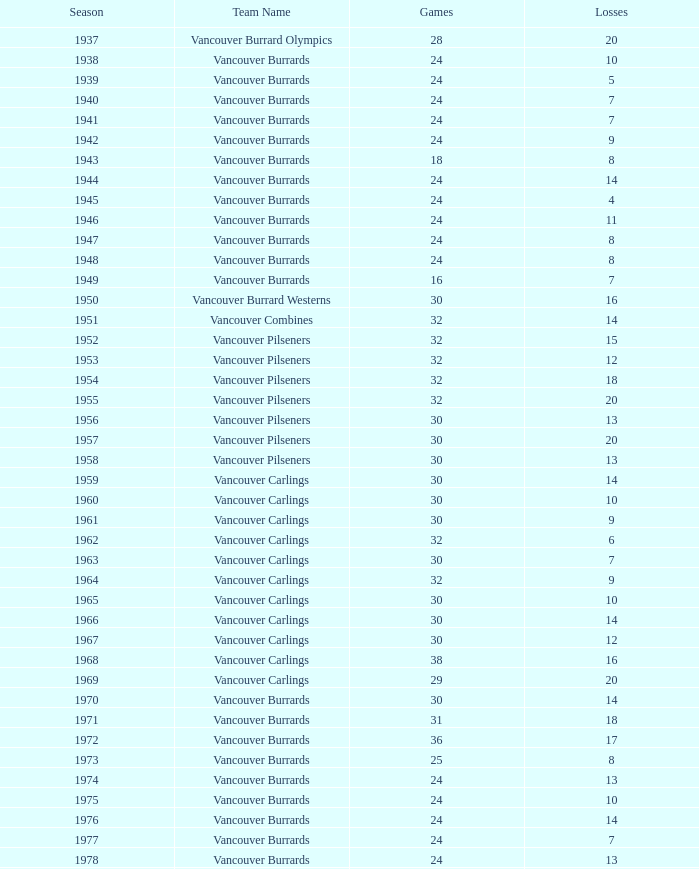What is the cumulative point count when the vancouver burrards experience under 9 losses and beyond 24 games? 1.0. 